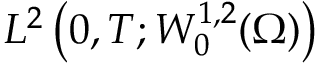<formula> <loc_0><loc_0><loc_500><loc_500>L ^ { 2 } \left ( 0 , T ; W _ { 0 } ^ { 1 , 2 } ( \Omega ) \right )</formula> 